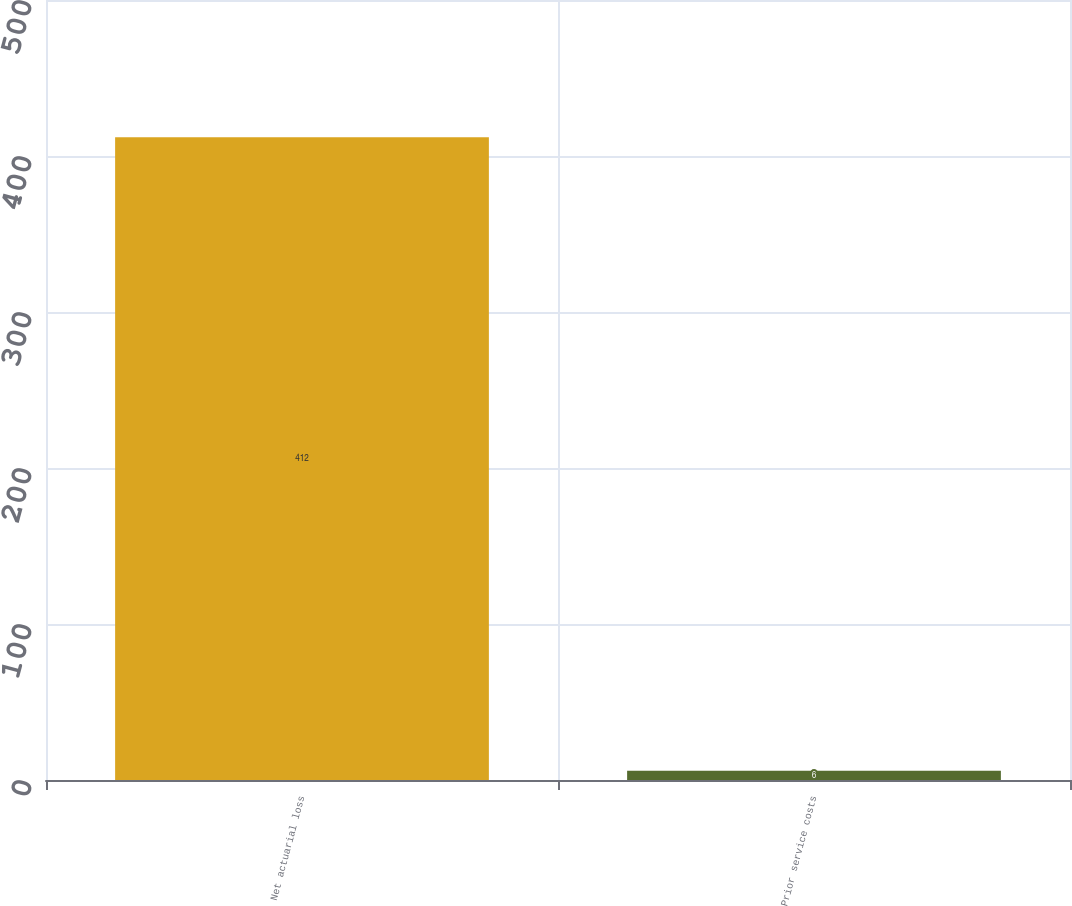Convert chart to OTSL. <chart><loc_0><loc_0><loc_500><loc_500><bar_chart><fcel>Net actuarial loss<fcel>Prior service costs<nl><fcel>412<fcel>6<nl></chart> 